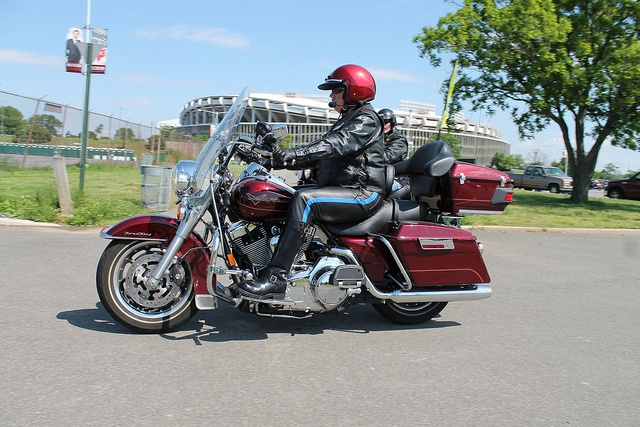Describe the objects in this image and their specific colors. I can see motorcycle in lightblue, black, darkgray, gray, and maroon tones, people in lightblue, black, gray, darkgray, and lightgray tones, truck in lightblue, purple, black, darkgray, and gray tones, people in lightblue, black, gray, and darkgray tones, and truck in lightblue, black, and gray tones in this image. 